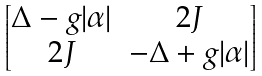Convert formula to latex. <formula><loc_0><loc_0><loc_500><loc_500>\begin{bmatrix} \Delta - g | \alpha | & 2 J \\ 2 J & - \Delta + g | \alpha | \\ \end{bmatrix}</formula> 